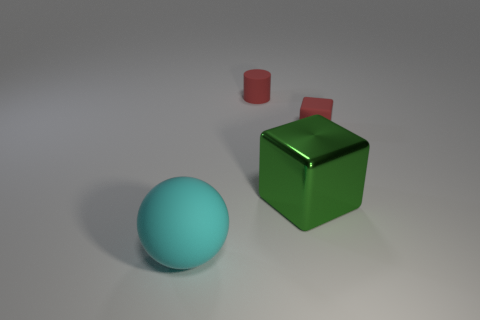What number of green metallic blocks have the same size as the cyan sphere?
Your answer should be compact. 1. Are there any small brown rubber cylinders?
Keep it short and to the point. No. Are there any other things of the same color as the ball?
Make the answer very short. No. The cyan thing that is the same material as the red cylinder is what shape?
Make the answer very short. Sphere. What color is the rubber thing that is right of the tiny red matte object left of the rubber object to the right of the small cylinder?
Your response must be concise. Red. Are there an equal number of large metal blocks right of the large cyan matte sphere and purple cylinders?
Provide a succinct answer. No. Is there anything else that has the same material as the green cube?
Offer a terse response. No. There is a matte cylinder; is its color the same as the tiny object right of the green metallic thing?
Provide a succinct answer. Yes. There is a red thing right of the red thing behind the small cube; is there a large ball on the right side of it?
Provide a succinct answer. No. Is the number of red matte objects that are in front of the tiny red cylinder less than the number of small blue metallic cylinders?
Offer a very short reply. No. 